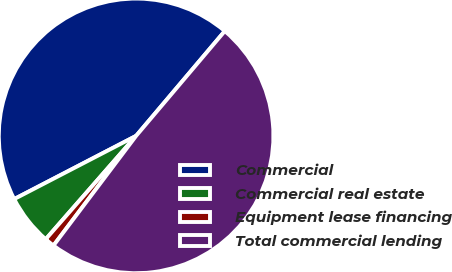Convert chart. <chart><loc_0><loc_0><loc_500><loc_500><pie_chart><fcel>Commercial<fcel>Commercial real estate<fcel>Equipment lease financing<fcel>Total commercial lending<nl><fcel>43.79%<fcel>5.95%<fcel>1.16%<fcel>49.1%<nl></chart> 